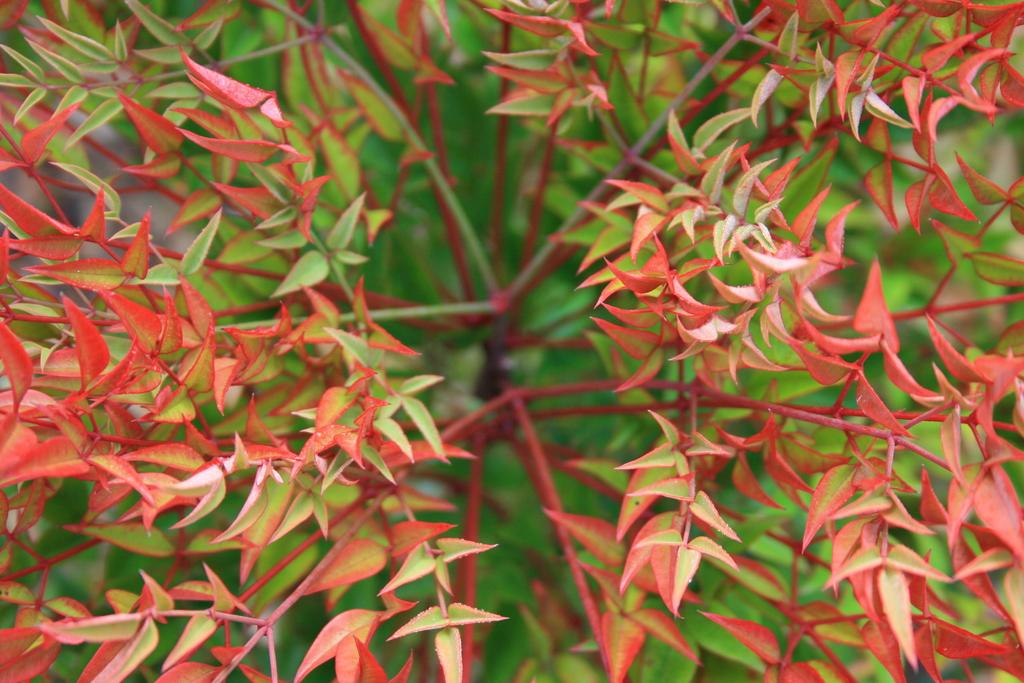What color are some of the leaves on the plant in the image? There are orange leaves on the plant. What color are the other leaves on the plant? There are green leaves on the plant. Can you touch the slope in the image? There is no slope present in the image; it features a plant with orange and green leaves. What does the plant smell like in the image? The image does not provide information about the scent of the plant, so it cannot be determined from the image. 